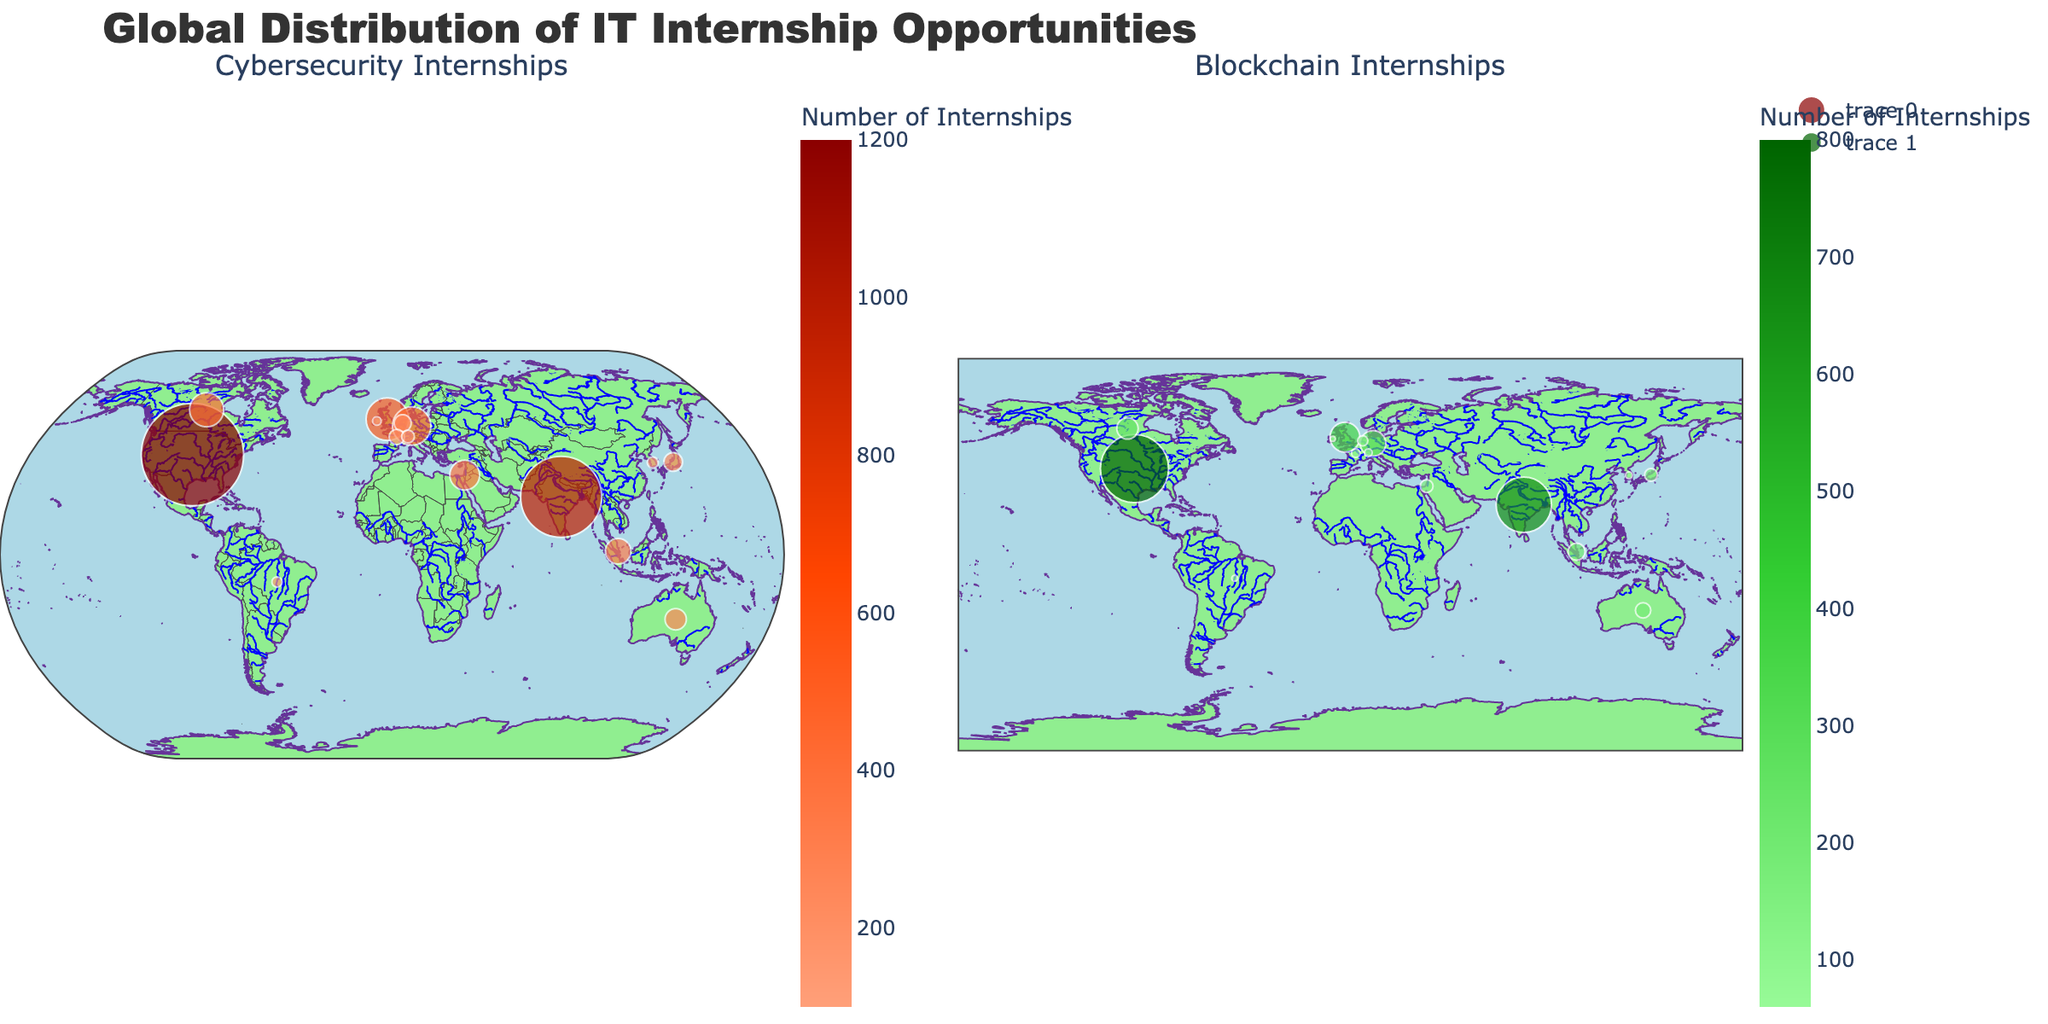How many cybersecurity internships are available in the United States? Look for the United States on the left-hand side of the figure under "Cybersecurity Internships" and read the value provided for the number of internships.
Answer: 1200 Which two countries have the highest number of blockchain internships? To find the two countries with the highest number of blockchain internships, observe the right-hand side of the figure under "Blockchain Internships" and identify the two nations with the largest markers or highest values.
Answer: United States and India What is the difference in the number of cybersecurity internships between the United States and India? Identify the number of cybersecurity internships in the United States (1200) and India (950) from the left-hand side of the figure. Subtract India's count from that of the United States: 1200 - 950.
Answer: 250 Are there more blockchain internships available in Canada or Israel? Compare the sizes and values of the markers for Canada and Israel on the right-hand side of the figure under "Blockchain Internships".
Answer: Canada Which country appears to have a balanced number of both cybersecurity and blockchain internships? Find a country that has similarly sized markers on both the left-hand and right-hand sides of the figure. Israel, with 350 cybersecurity and 150 blockchain internships, seems relatively balanced.
Answer: Israel What is the total number of cybersecurity internships available in European countries listed? Sum the number of cybersecurity internships for European countries listed in the figure: United Kingdom (500), Germany (450), Netherlands (200), France (180), Switzerland (150). Total is 500 + 450 + 200 + 180 + 150.
Answer: 1480 Which region, based on the appearance of the figure, shows a higher concentration of IT internships in both fields, Northern America or Asia? Compare the sizes and density of markers in Northern America (United States, Canada) and Asia (India, Japan, South Korea, Singapore). Northern America has larger markers overall, indicating higher internship opportunities.
Answer: Northern America How does the number of blockchain internships in Germany compare to those in France? Locate Germany and France on the right-hand side of the figure under "Blockchain Internships" and compare their values or marker sizes. Germany has 300 and France has 100.
Answer: Germany has more Which country has the lowest number of cybersecurity internships according to the plot? Identify the smallest marker on the left-hand side of the figure under "Cybersecurity Internships". The smallest value corresponds to Ireland.
Answer: Ireland What is the average number of blockchain internships across all countries listed? Sum the blockchain internships for all listed countries and divide by the number of countries (15): (800 + 650 + 350 + 300 + 250 + 150 + 200 + 180 + 150 + 120 + 100 + 90 + 80 + 70 + 60) / 15. The sum is 3550, so the average is 3550 / 15.
Answer: ~237 